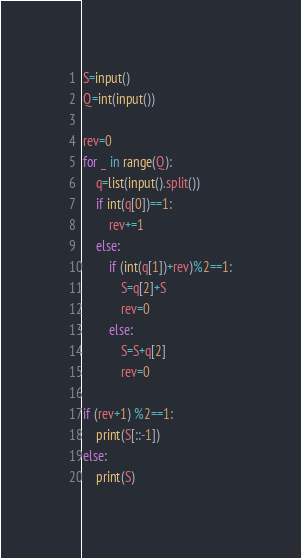<code> <loc_0><loc_0><loc_500><loc_500><_Python_>S=input()
Q=int(input())

rev=0
for _ in range(Q):
    q=list(input().split())
    if int(q[0])==1:
        rev+=1
    else:
        if (int(q[1])+rev)%2==1:
            S=q[2]+S
            rev=0
        else:
            S=S+q[2]
            rev=0

if (rev+1) %2==1:
    print(S[::-1])
else:
    print(S)</code> 